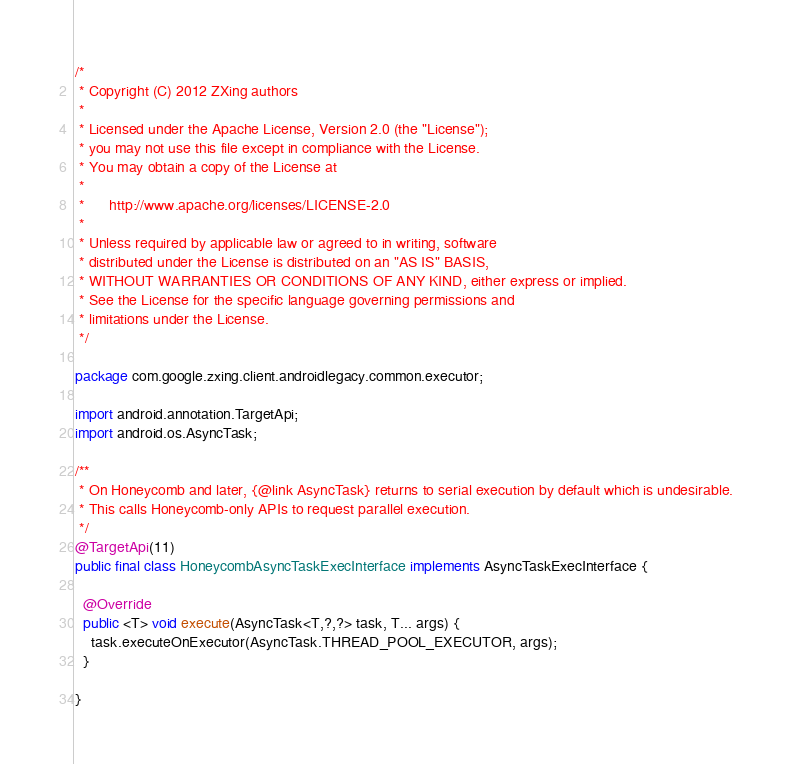Convert code to text. <code><loc_0><loc_0><loc_500><loc_500><_Java_>/*
 * Copyright (C) 2012 ZXing authors
 *
 * Licensed under the Apache License, Version 2.0 (the "License");
 * you may not use this file except in compliance with the License.
 * You may obtain a copy of the License at
 *
 *      http://www.apache.org/licenses/LICENSE-2.0
 *
 * Unless required by applicable law or agreed to in writing, software
 * distributed under the License is distributed on an "AS IS" BASIS,
 * WITHOUT WARRANTIES OR CONDITIONS OF ANY KIND, either express or implied.
 * See the License for the specific language governing permissions and
 * limitations under the License.
 */

package com.google.zxing.client.androidlegacy.common.executor;

import android.annotation.TargetApi;
import android.os.AsyncTask;

/**
 * On Honeycomb and later, {@link AsyncTask} returns to serial execution by default which is undesirable.
 * This calls Honeycomb-only APIs to request parallel execution.
 */
@TargetApi(11)
public final class HoneycombAsyncTaskExecInterface implements AsyncTaskExecInterface {

  @Override
  public <T> void execute(AsyncTask<T,?,?> task, T... args) {
    task.executeOnExecutor(AsyncTask.THREAD_POOL_EXECUTOR, args);
  }

}
</code> 